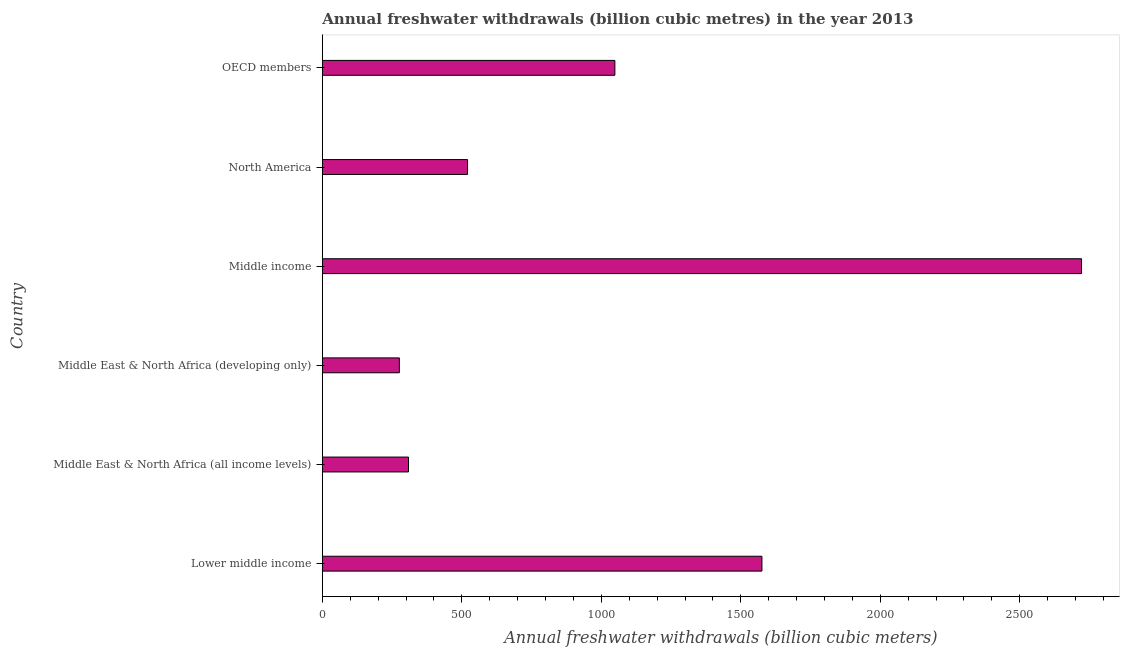Does the graph contain grids?
Keep it short and to the point. No. What is the title of the graph?
Your answer should be very brief. Annual freshwater withdrawals (billion cubic metres) in the year 2013. What is the label or title of the X-axis?
Make the answer very short. Annual freshwater withdrawals (billion cubic meters). What is the label or title of the Y-axis?
Offer a very short reply. Country. What is the annual freshwater withdrawals in Middle income?
Offer a very short reply. 2721.34. Across all countries, what is the maximum annual freshwater withdrawals?
Give a very brief answer. 2721.34. Across all countries, what is the minimum annual freshwater withdrawals?
Provide a short and direct response. 276.12. In which country was the annual freshwater withdrawals maximum?
Your response must be concise. Middle income. In which country was the annual freshwater withdrawals minimum?
Your answer should be very brief. Middle East & North Africa (developing only). What is the sum of the annual freshwater withdrawals?
Make the answer very short. 6451.28. What is the difference between the annual freshwater withdrawals in Middle East & North Africa (all income levels) and Middle income?
Your response must be concise. -2412.51. What is the average annual freshwater withdrawals per country?
Your answer should be very brief. 1075.21. What is the median annual freshwater withdrawals?
Your answer should be compact. 784.61. In how many countries, is the annual freshwater withdrawals greater than 2600 billion cubic meters?
Provide a short and direct response. 1. What is the ratio of the annual freshwater withdrawals in Middle East & North Africa (developing only) to that in Middle income?
Keep it short and to the point. 0.1. What is the difference between the highest and the second highest annual freshwater withdrawals?
Your answer should be very brief. 1145.57. Is the sum of the annual freshwater withdrawals in Lower middle income and North America greater than the maximum annual freshwater withdrawals across all countries?
Offer a very short reply. No. What is the difference between the highest and the lowest annual freshwater withdrawals?
Your response must be concise. 2445.22. Are all the bars in the graph horizontal?
Make the answer very short. Yes. How many countries are there in the graph?
Make the answer very short. 6. Are the values on the major ticks of X-axis written in scientific E-notation?
Your response must be concise. No. What is the Annual freshwater withdrawals (billion cubic meters) in Lower middle income?
Ensure brevity in your answer.  1575.78. What is the Annual freshwater withdrawals (billion cubic meters) of Middle East & North Africa (all income levels)?
Offer a terse response. 308.83. What is the Annual freshwater withdrawals (billion cubic meters) of Middle East & North Africa (developing only)?
Your response must be concise. 276.12. What is the Annual freshwater withdrawals (billion cubic meters) of Middle income?
Provide a short and direct response. 2721.34. What is the Annual freshwater withdrawals (billion cubic meters) of North America?
Provide a short and direct response. 520.6. What is the Annual freshwater withdrawals (billion cubic meters) in OECD members?
Offer a terse response. 1048.61. What is the difference between the Annual freshwater withdrawals (billion cubic meters) in Lower middle income and Middle East & North Africa (all income levels)?
Keep it short and to the point. 1266.94. What is the difference between the Annual freshwater withdrawals (billion cubic meters) in Lower middle income and Middle East & North Africa (developing only)?
Ensure brevity in your answer.  1299.65. What is the difference between the Annual freshwater withdrawals (billion cubic meters) in Lower middle income and Middle income?
Your response must be concise. -1145.57. What is the difference between the Annual freshwater withdrawals (billion cubic meters) in Lower middle income and North America?
Keep it short and to the point. 1055.18. What is the difference between the Annual freshwater withdrawals (billion cubic meters) in Lower middle income and OECD members?
Provide a succinct answer. 527.17. What is the difference between the Annual freshwater withdrawals (billion cubic meters) in Middle East & North Africa (all income levels) and Middle East & North Africa (developing only)?
Offer a very short reply. 32.71. What is the difference between the Annual freshwater withdrawals (billion cubic meters) in Middle East & North Africa (all income levels) and Middle income?
Give a very brief answer. -2412.51. What is the difference between the Annual freshwater withdrawals (billion cubic meters) in Middle East & North Africa (all income levels) and North America?
Offer a terse response. -211.77. What is the difference between the Annual freshwater withdrawals (billion cubic meters) in Middle East & North Africa (all income levels) and OECD members?
Provide a short and direct response. -739.78. What is the difference between the Annual freshwater withdrawals (billion cubic meters) in Middle East & North Africa (developing only) and Middle income?
Give a very brief answer. -2445.22. What is the difference between the Annual freshwater withdrawals (billion cubic meters) in Middle East & North Africa (developing only) and North America?
Your answer should be compact. -244.48. What is the difference between the Annual freshwater withdrawals (billion cubic meters) in Middle East & North Africa (developing only) and OECD members?
Your answer should be compact. -772.49. What is the difference between the Annual freshwater withdrawals (billion cubic meters) in Middle income and North America?
Provide a succinct answer. 2200.74. What is the difference between the Annual freshwater withdrawals (billion cubic meters) in Middle income and OECD members?
Ensure brevity in your answer.  1672.73. What is the difference between the Annual freshwater withdrawals (billion cubic meters) in North America and OECD members?
Provide a short and direct response. -528.01. What is the ratio of the Annual freshwater withdrawals (billion cubic meters) in Lower middle income to that in Middle East & North Africa (all income levels)?
Make the answer very short. 5.1. What is the ratio of the Annual freshwater withdrawals (billion cubic meters) in Lower middle income to that in Middle East & North Africa (developing only)?
Your answer should be compact. 5.71. What is the ratio of the Annual freshwater withdrawals (billion cubic meters) in Lower middle income to that in Middle income?
Your answer should be compact. 0.58. What is the ratio of the Annual freshwater withdrawals (billion cubic meters) in Lower middle income to that in North America?
Your response must be concise. 3.03. What is the ratio of the Annual freshwater withdrawals (billion cubic meters) in Lower middle income to that in OECD members?
Offer a very short reply. 1.5. What is the ratio of the Annual freshwater withdrawals (billion cubic meters) in Middle East & North Africa (all income levels) to that in Middle East & North Africa (developing only)?
Provide a succinct answer. 1.12. What is the ratio of the Annual freshwater withdrawals (billion cubic meters) in Middle East & North Africa (all income levels) to that in Middle income?
Provide a short and direct response. 0.11. What is the ratio of the Annual freshwater withdrawals (billion cubic meters) in Middle East & North Africa (all income levels) to that in North America?
Provide a succinct answer. 0.59. What is the ratio of the Annual freshwater withdrawals (billion cubic meters) in Middle East & North Africa (all income levels) to that in OECD members?
Your answer should be very brief. 0.29. What is the ratio of the Annual freshwater withdrawals (billion cubic meters) in Middle East & North Africa (developing only) to that in Middle income?
Provide a succinct answer. 0.1. What is the ratio of the Annual freshwater withdrawals (billion cubic meters) in Middle East & North Africa (developing only) to that in North America?
Give a very brief answer. 0.53. What is the ratio of the Annual freshwater withdrawals (billion cubic meters) in Middle East & North Africa (developing only) to that in OECD members?
Offer a very short reply. 0.26. What is the ratio of the Annual freshwater withdrawals (billion cubic meters) in Middle income to that in North America?
Give a very brief answer. 5.23. What is the ratio of the Annual freshwater withdrawals (billion cubic meters) in Middle income to that in OECD members?
Offer a very short reply. 2.6. What is the ratio of the Annual freshwater withdrawals (billion cubic meters) in North America to that in OECD members?
Offer a terse response. 0.5. 